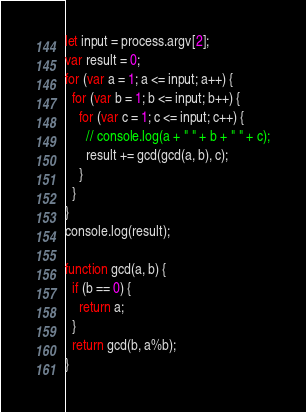Convert code to text. <code><loc_0><loc_0><loc_500><loc_500><_JavaScript_>let input = process.argv[2];
var result = 0;
for (var a = 1; a <= input; a++) {
  for (var b = 1; b <= input; b++) {
    for (var c = 1; c <= input; c++) {
      // console.log(a + " " + b + " " + c);
      result += gcd(gcd(a, b), c);
    }
  }
}
console.log(result);

function gcd(a, b) {  
  if (b == 0) {
    return a;
  }
  return gcd(b, a%b);
}
</code> 